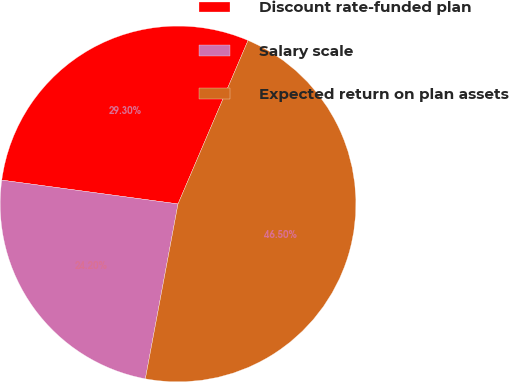Convert chart to OTSL. <chart><loc_0><loc_0><loc_500><loc_500><pie_chart><fcel>Discount rate-funded plan<fcel>Salary scale<fcel>Expected return on plan assets<nl><fcel>29.3%<fcel>24.2%<fcel>46.5%<nl></chart> 